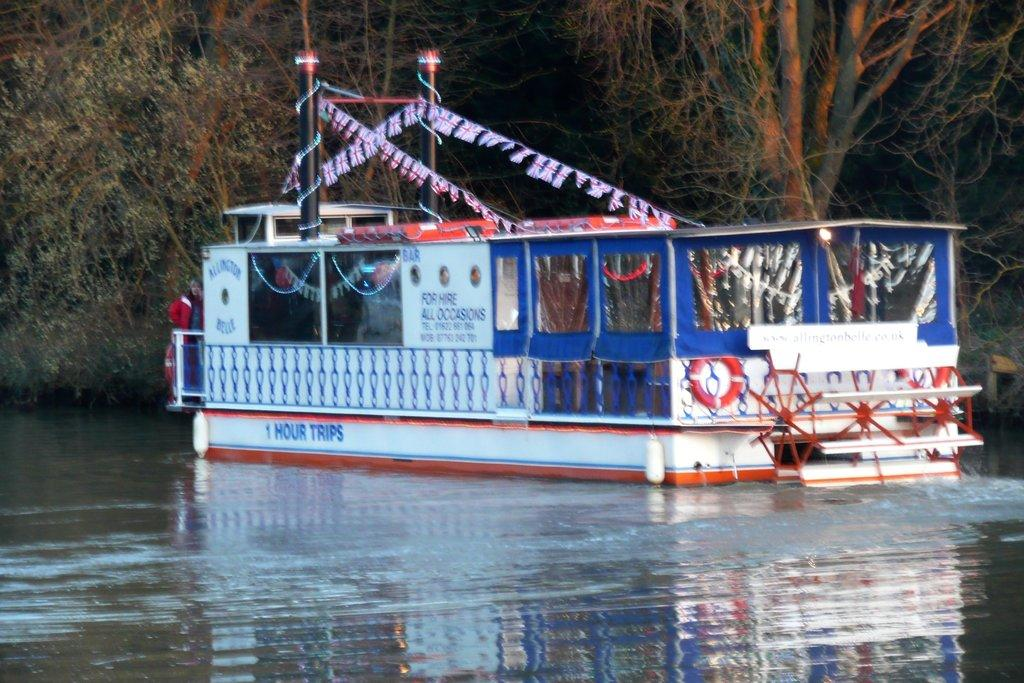What is the main subject of the image? The main subject of the image is a boat. Where is the boat located? The boat is on the water. What can be seen on the boat? There are decorations on the boat, and something is written on it. What can be seen in the background of the image? There are trees visible in the background. How many eggs are visible on the boat in the image? There are no eggs visible on the boat in the image. What type of error is being corrected on the boat in the image? There is no error being corrected on the boat in the image. 